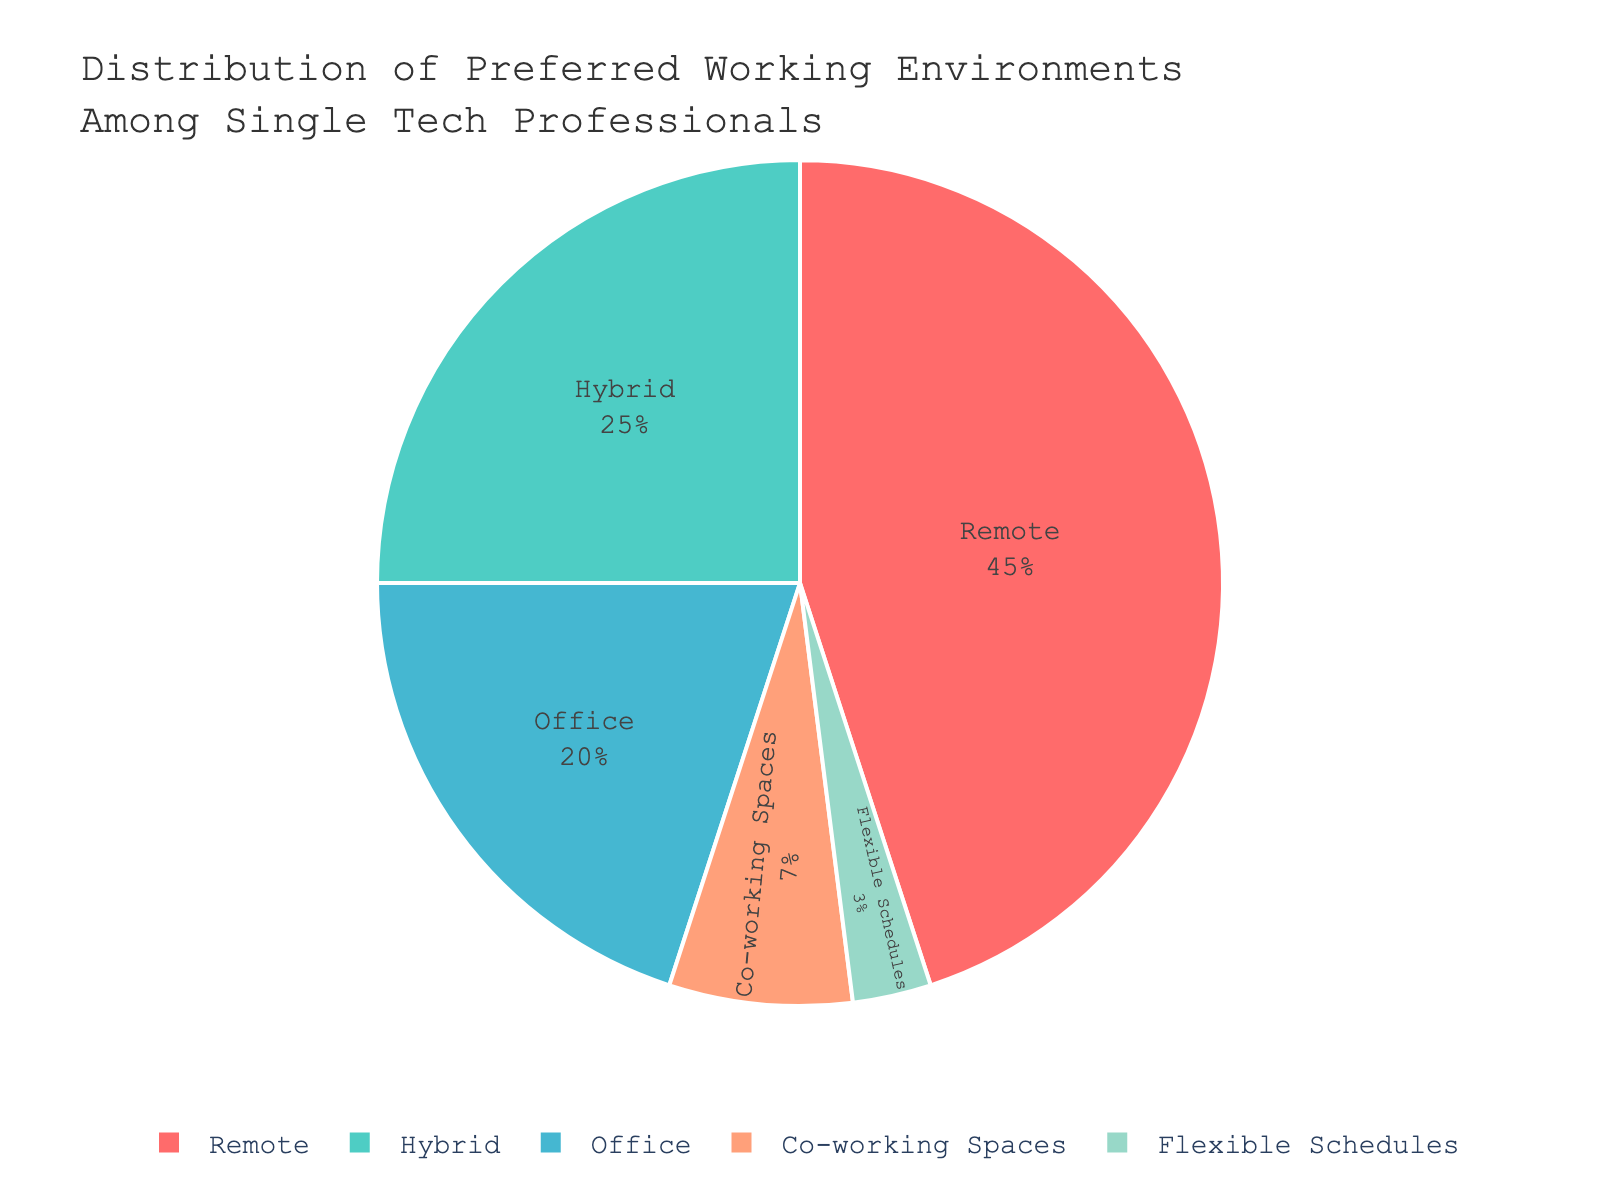What's the most preferred working environment among single tech professionals? The pie chart shows the distribution of preferred working environments among single tech professionals, and the largest slice of the pie chart represents the most preferred option. In this case, the largest slice is labeled "Remote".
Answer: Remote Which working environment is least preferred among single tech professionals? The pie chart shows various segments representing different working environments. The smallest slice represents the least preferred option, which here is labeled "Flexible Schedules".
Answer: Flexible Schedules What percentage of single tech professionals prefer working either in a "Hybrid" environment or "Office"? To find the combined percentage, add the percentages of "Hybrid" and "Office" from the pie chart. The percentage for "Hybrid" is 25%, and for "Office," it is 20%. The sum is 25% + 20% = 45%.
Answer: 45% By how much does the preference for "Remote" exceed the preference for "Office" among single tech professionals? Check the percentages for "Remote" and "Office" from the pie chart. "Remote" has 45%, and "Office" has 20%. Subtract the percentage of "Office" from "Remote": 45% - 20% = 25%.
Answer: 25% Is "Hybrid" more preferred than "Office," and if so, by how much? Compare the percentages for "Hybrid" and "Office" from the pie chart. "Hybrid" has 25%, and "Office" has 20%. Calculate the difference: 25% - 20% = 5%.
Answer: Yes, by 5% Calculate the combined percentage of single tech professionals who prefer working environments classified as either "Co-working Spaces" or "Flexible Schedules". Add the percentages from the pie chart for "Co-working Spaces" and "Flexible Schedules." "Co-working Spaces" have 7%, and "Flexible Schedules" have 3%. The sum is 7% + 3% = 10%.
Answer: 10% What color is used to represent the "Remote" working environment in the pie chart? The pie chart uses a specific color palette for each segment. The "Remote" working environment is marked with red.
Answer: Red Compare the combined preference for "Co-working Spaces" and "Flexible Schedules" to the preference for "Hybrid." Which is higher, and by what percentage? From the pie chart, sum the percentages for "Co-working Spaces" (7%) and "Flexible Schedules" (3%), resulting in 10%. Then compare it to the percentage for "Hybrid" (25%). The preference for "Hybrid" is higher by 25% - 10% = 15%.
Answer: Hybrid is higher by 15% Which working environment has the second-highest preference among single tech professionals? Looking at the pie chart, the second-largest segment will indicate the second-highest preference. The "Hybrid" segment is the second-largest with 25%.
Answer: Hybrid 